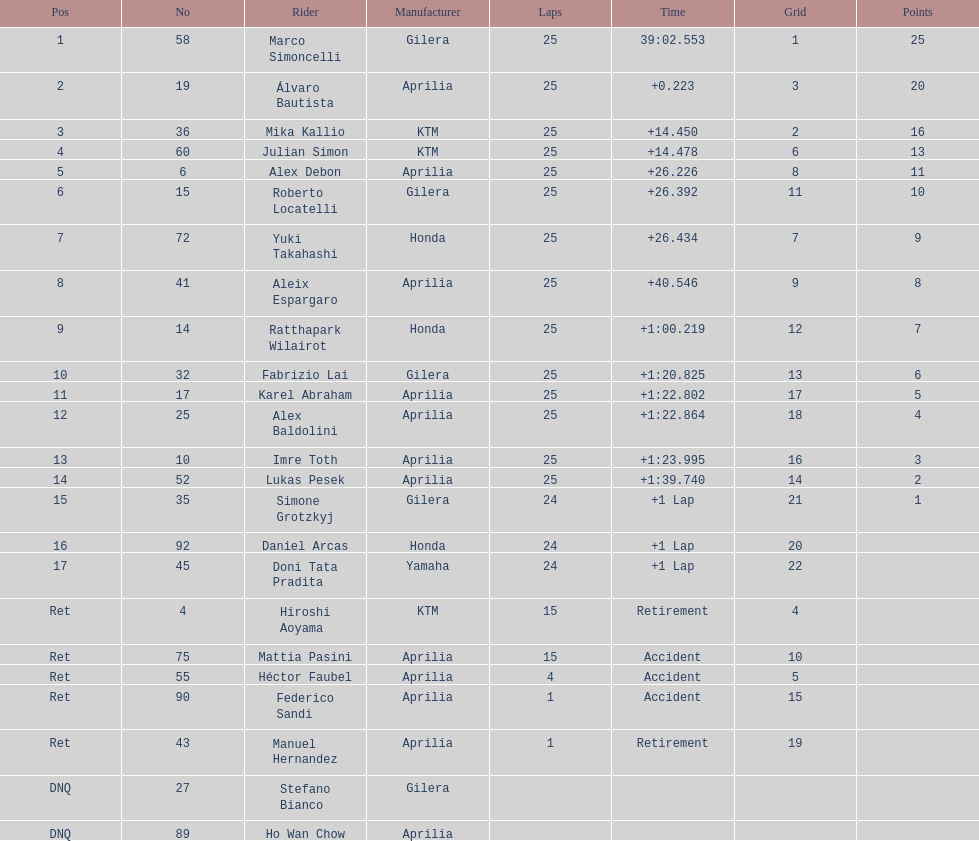What's the total count of laps imre toth has accomplished? 25. 